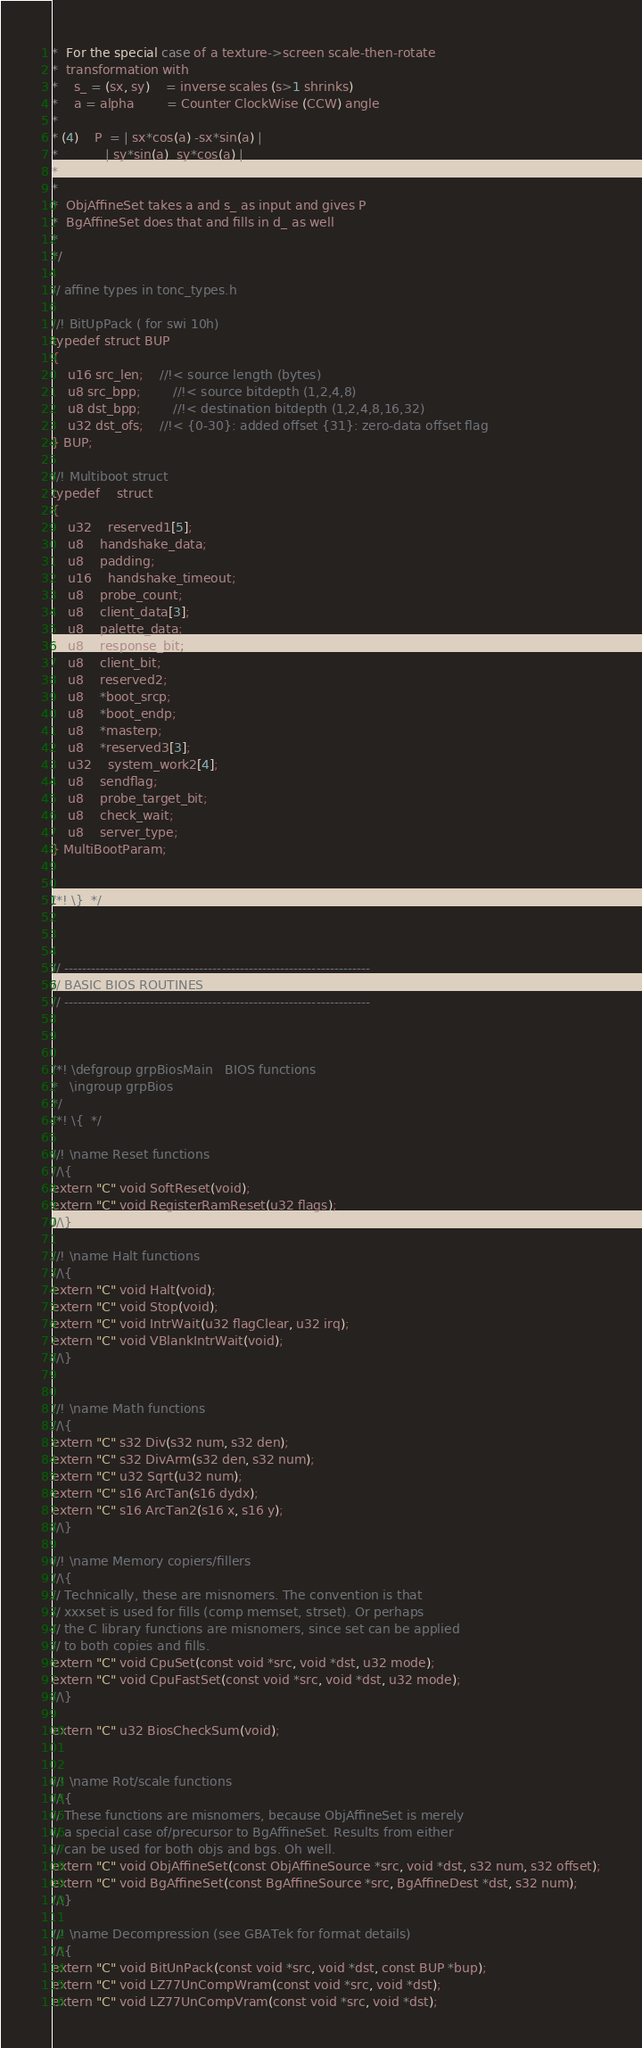Convert code to text. <code><loc_0><loc_0><loc_500><loc_500><_C_>*  For the special case of a texture->screen scale-then-rotate
*  transformation with
*	s_ = (sx, sy)	= inverse scales (s>1 shrinks)
*	a = alpha		= Counter ClockWise (CCW) angle
*
* (4)	P  = | sx*cos(a) -sx*sin(a) |
*            | sy*sin(a)  sy*cos(a) |
*
*
*  ObjAffineSet takes a and s_ as input and gives P
*  BgAffineSet does that and fills in d_ as well
*
*/

// affine types in tonc_types.h

//! BitUpPack ( for swi 10h)
typedef struct BUP
{
	u16 src_len;	//!< source length (bytes)
	u8 src_bpp;		//!< source bitdepth (1,2,4,8)
	u8 dst_bpp;		//!< destination bitdepth (1,2,4,8,16,32)
	u32 dst_ofs;	//!< {0-30}: added offset {31}: zero-data offset flag
} BUP;

//! Multiboot struct
typedef	struct
{
	u32	reserved1[5];
	u8	handshake_data;
	u8	padding;
	u16	handshake_timeout;
	u8	probe_count;
	u8	client_data[3];
	u8	palette_data;
	u8	response_bit;
	u8	client_bit;
	u8	reserved2;
	u8	*boot_srcp;
	u8	*boot_endp;
	u8	*masterp;
	u8	*reserved3[3];
	u32	system_work2[4];
	u8	sendflag;
	u8	probe_target_bit;
	u8	check_wait;
	u8	server_type;
} MultiBootParam;


/*!	\}	*/



// --------------------------------------------------------------------
// BASIC BIOS ROUTINES
// --------------------------------------------------------------------



/*!	\defgroup grpBiosMain	BIOS functions
*	\ingroup grpBios
*/
/*! \{	*/

//! \name Reset functions
//\{
extern "C" void SoftReset(void);
extern "C" void RegisterRamReset(u32 flags);
//\}

//! \name Halt functions
//\{
extern "C" void Halt(void);
extern "C" void Stop(void);
extern "C" void IntrWait(u32 flagClear, u32 irq);
extern "C" void VBlankIntrWait(void);
//\}


//! \name Math functions
//\{
extern "C" s32 Div(s32 num, s32 den);
extern "C" s32 DivArm(s32 den, s32 num);
extern "C" u32 Sqrt(u32 num);
extern "C" s16 ArcTan(s16 dydx);
extern "C" s16 ArcTan2(s16 x, s16 y);
//\}

//! \name Memory copiers/fillers
//\{
// Technically, these are misnomers. The convention is that
// xxxset is used for fills (comp memset, strset). Or perhaps
// the C library functions are misnomers, since set can be applied
// to both copies and fills.
extern "C" void CpuSet(const void *src, void *dst, u32 mode);
extern "C" void CpuFastSet(const void *src, void *dst, u32 mode);
//\}

extern "C" u32 BiosCheckSum(void);


//! \name Rot/scale functions
//\{
// These functions are misnomers, because ObjAffineSet is merely
// a special case of/precursor to BgAffineSet. Results from either
// can be used for both objs and bgs. Oh well.
extern "C" void ObjAffineSet(const ObjAffineSource *src, void *dst, s32 num, s32 offset);
extern "C" void BgAffineSet(const BgAffineSource *src, BgAffineDest *dst, s32 num);
//\}

//! \name Decompression (see GBATek for format details)
//\{
extern "C" void BitUnPack(const void *src, void *dst, const BUP *bup);
extern "C" void LZ77UnCompWram(const void *src, void *dst);
extern "C" void LZ77UnCompVram(const void *src, void *dst);</code> 